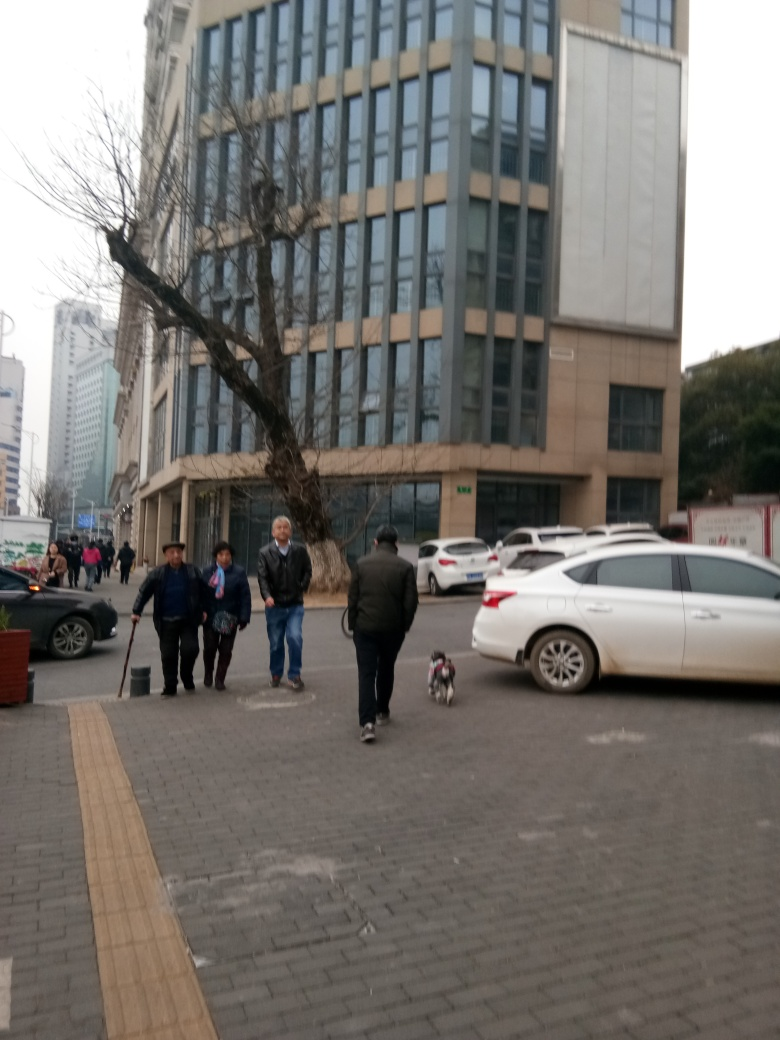Are the people in the foreground poorly presented? The assessment of the people's presentation in the foreground is subjective and based on personal standards of appearance; from the image, they appear to be dressed in ordinary streetwear suitable for an urban environment, suggesting a casual and practical attire rather than being poorly presented. 